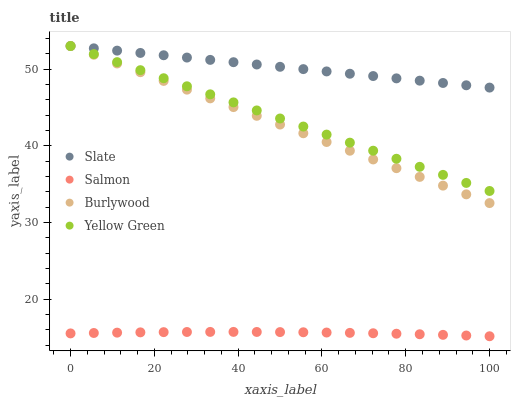Does Salmon have the minimum area under the curve?
Answer yes or no. Yes. Does Slate have the maximum area under the curve?
Answer yes or no. Yes. Does Slate have the minimum area under the curve?
Answer yes or no. No. Does Salmon have the maximum area under the curve?
Answer yes or no. No. Is Burlywood the smoothest?
Answer yes or no. Yes. Is Salmon the roughest?
Answer yes or no. Yes. Is Slate the smoothest?
Answer yes or no. No. Is Slate the roughest?
Answer yes or no. No. Does Salmon have the lowest value?
Answer yes or no. Yes. Does Slate have the lowest value?
Answer yes or no. No. Does Yellow Green have the highest value?
Answer yes or no. Yes. Does Salmon have the highest value?
Answer yes or no. No. Is Salmon less than Burlywood?
Answer yes or no. Yes. Is Yellow Green greater than Salmon?
Answer yes or no. Yes. Does Burlywood intersect Yellow Green?
Answer yes or no. Yes. Is Burlywood less than Yellow Green?
Answer yes or no. No. Is Burlywood greater than Yellow Green?
Answer yes or no. No. Does Salmon intersect Burlywood?
Answer yes or no. No. 